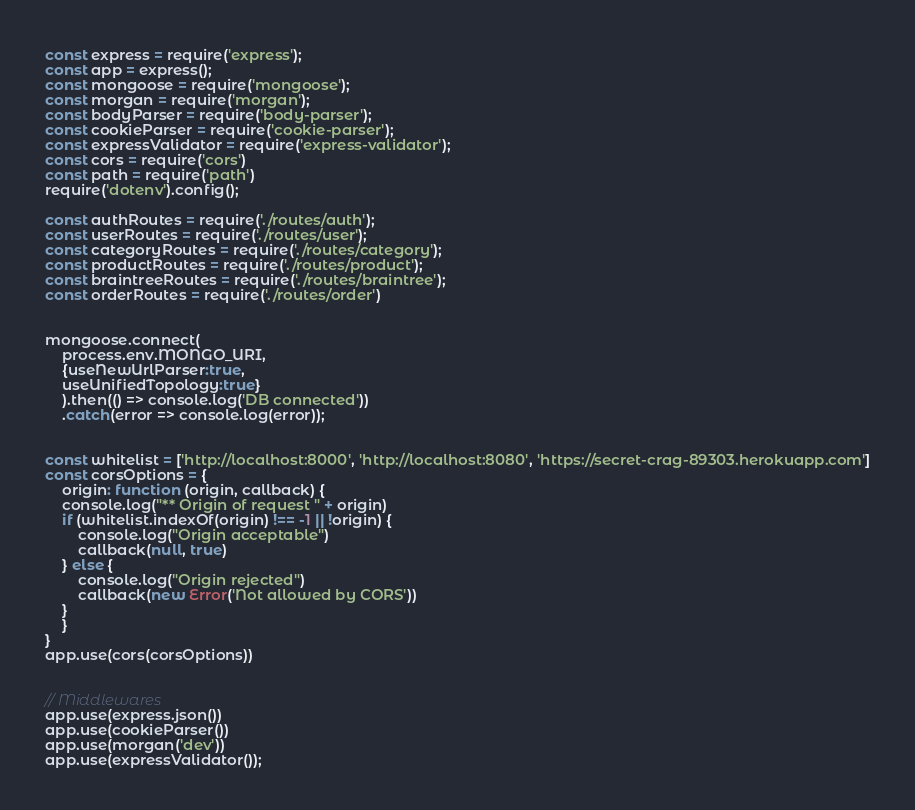Convert code to text. <code><loc_0><loc_0><loc_500><loc_500><_JavaScript_>const express = require('express');
const app = express();
const mongoose = require('mongoose');
const morgan = require('morgan');
const bodyParser = require('body-parser');
const cookieParser = require('cookie-parser');
const expressValidator = require('express-validator');
const cors = require('cors')
const path = require('path')
require('dotenv').config();

const authRoutes = require('./routes/auth');
const userRoutes = require('./routes/user');
const categoryRoutes = require('./routes/category');
const productRoutes = require('./routes/product');
const braintreeRoutes = require('./routes/braintree');
const orderRoutes = require('./routes/order')


mongoose.connect(
    process.env.MONGO_URI,
    {useNewUrlParser:true,
    useUnifiedTopology:true}
    ).then(() => console.log('DB connected'))
    .catch(error => console.log(error)); 
    

const whitelist = ['http://localhost:8000', 'http://localhost:8080', 'https://secret-crag-89303.herokuapp.com']
const corsOptions = {
    origin: function (origin, callback) {
    console.log("** Origin of request " + origin)
    if (whitelist.indexOf(origin) !== -1 || !origin) {
        console.log("Origin acceptable")
        callback(null, true)
    } else {
        console.log("Origin rejected")
        callback(new Error('Not allowed by CORS'))
    }
    }
}
app.use(cors(corsOptions))


// Middlewares
app.use(express.json())
app.use(cookieParser())    
app.use(morgan('dev'))
app.use(expressValidator());</code> 